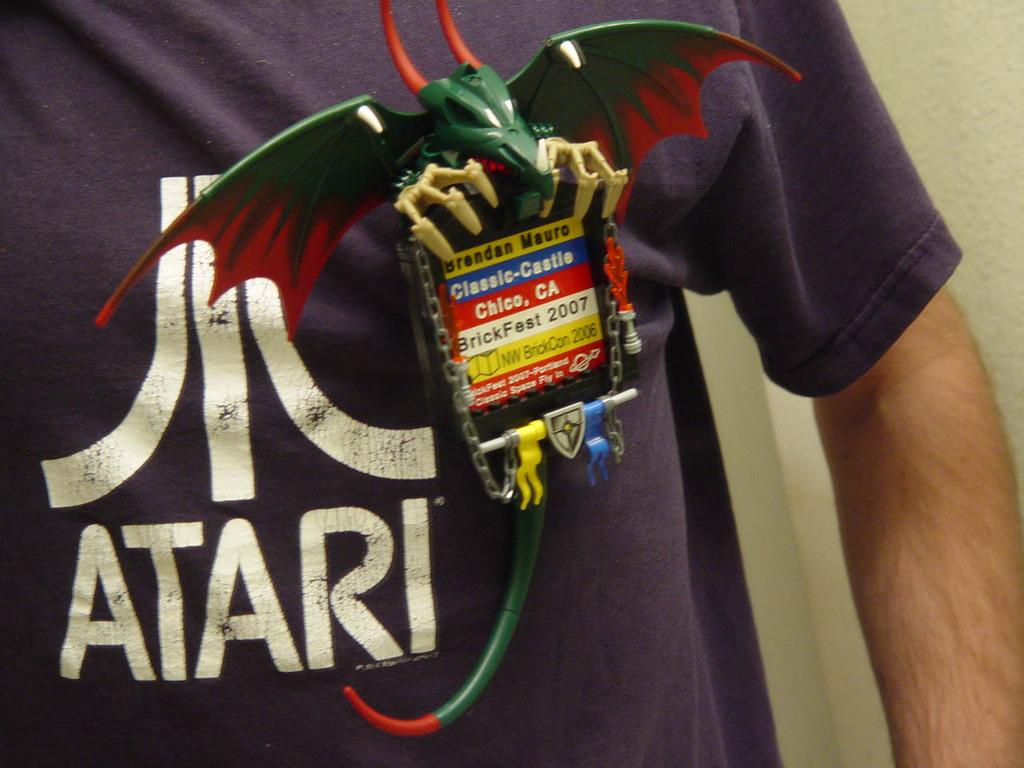<image>
Provide a brief description of the given image. a shirt that has the word atari on it 